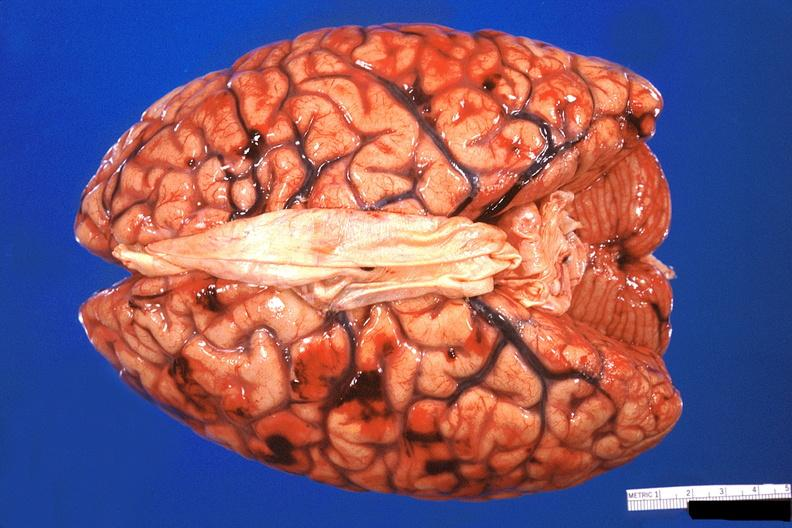does this image show brain, subarachanoid hemorrhage due to disseminated intravascular coagulation?
Answer the question using a single word or phrase. Yes 